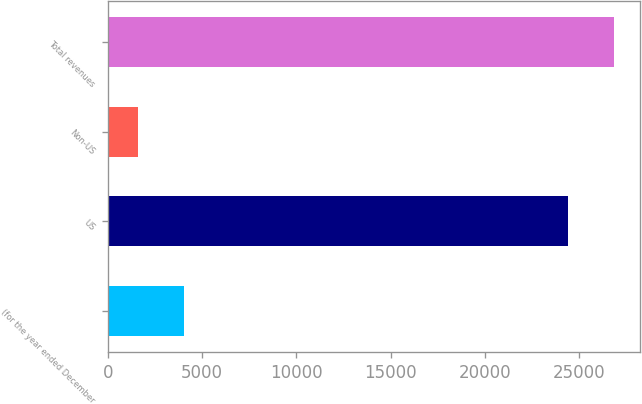Convert chart. <chart><loc_0><loc_0><loc_500><loc_500><bar_chart><fcel>(for the year ended December<fcel>US<fcel>Non-US<fcel>Total revenues<nl><fcel>4045.3<fcel>24413<fcel>1604<fcel>26854.3<nl></chart> 